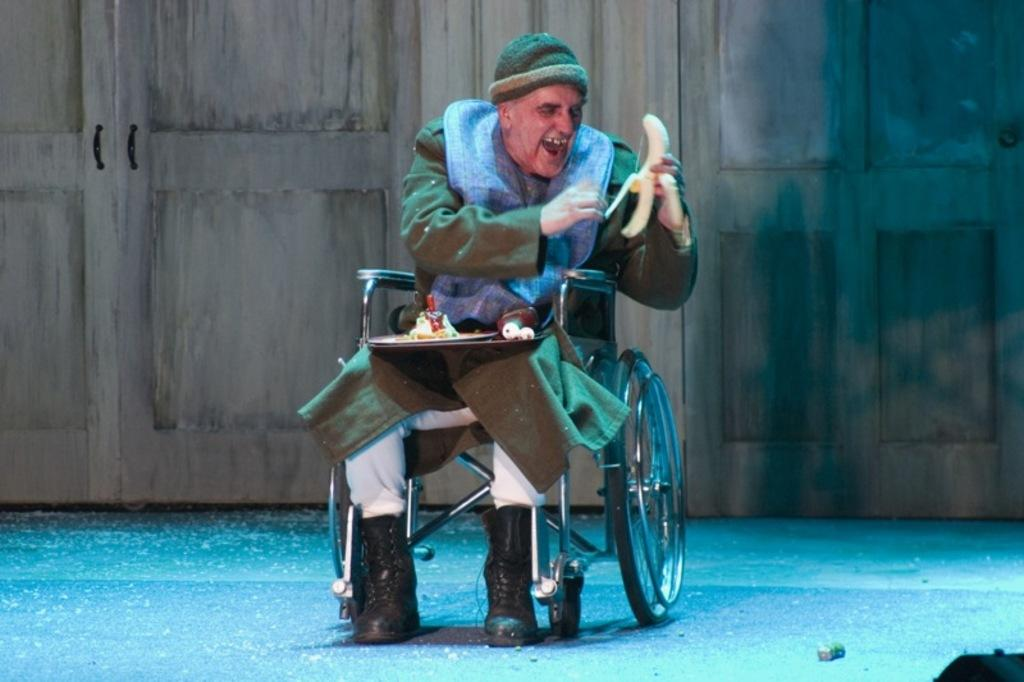Who is present in the image? There is a man in the image. What is the man holding in the image? The man is holding a banana. What is the man sitting on in the image? The man is sitting on a wheelchair. What type of doors can be seen in the background of the image? There are wooden doors in the background of the image. What type of current can be seen flowing through the ground in the image? There is no current or ground visible in the image; it features a man sitting on a wheelchair holding a banana. 